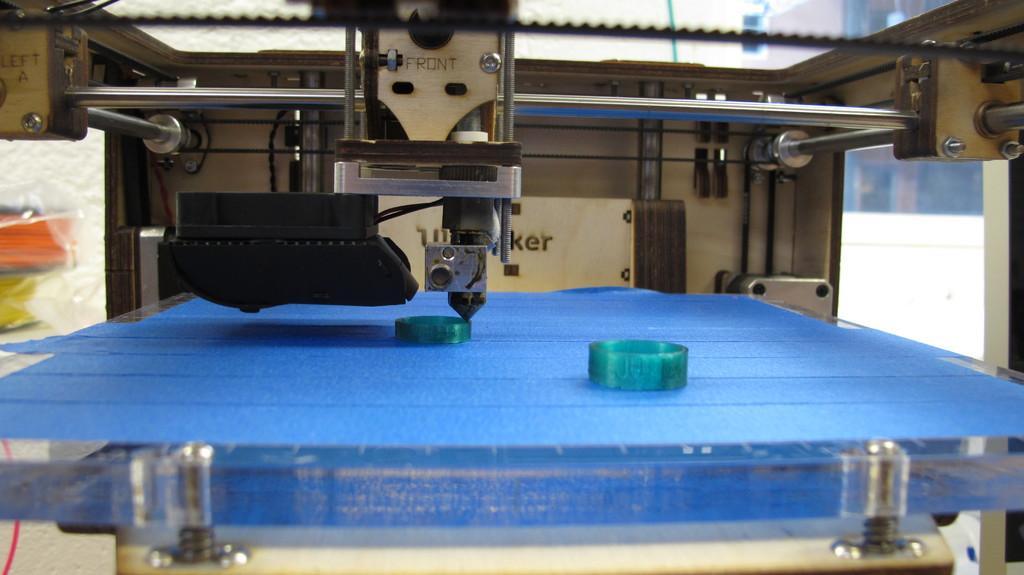How would you summarize this image in a sentence or two? At the bottom of the image there is a glass surface with blue cloth. And in the image there is a machine above the cloth. And also there are rods. And on the machine there are nuts. 